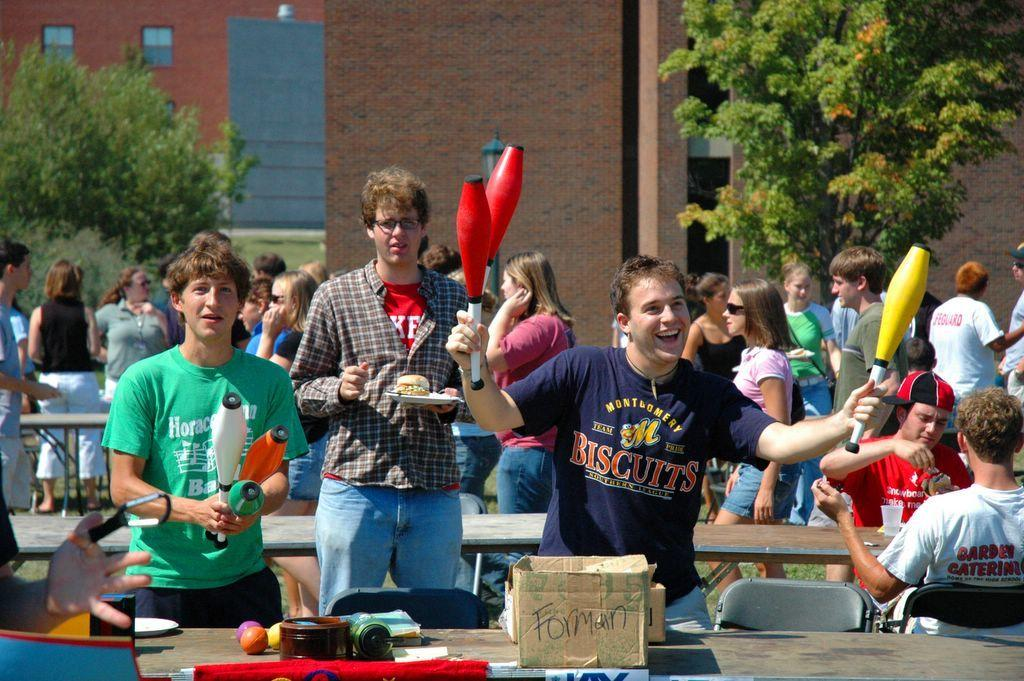Provide a one-sentence caption for the provided image. A man wearing a Montgomery Biscuits blue tee shirt is smiling while holding juggling pins in both hands. 